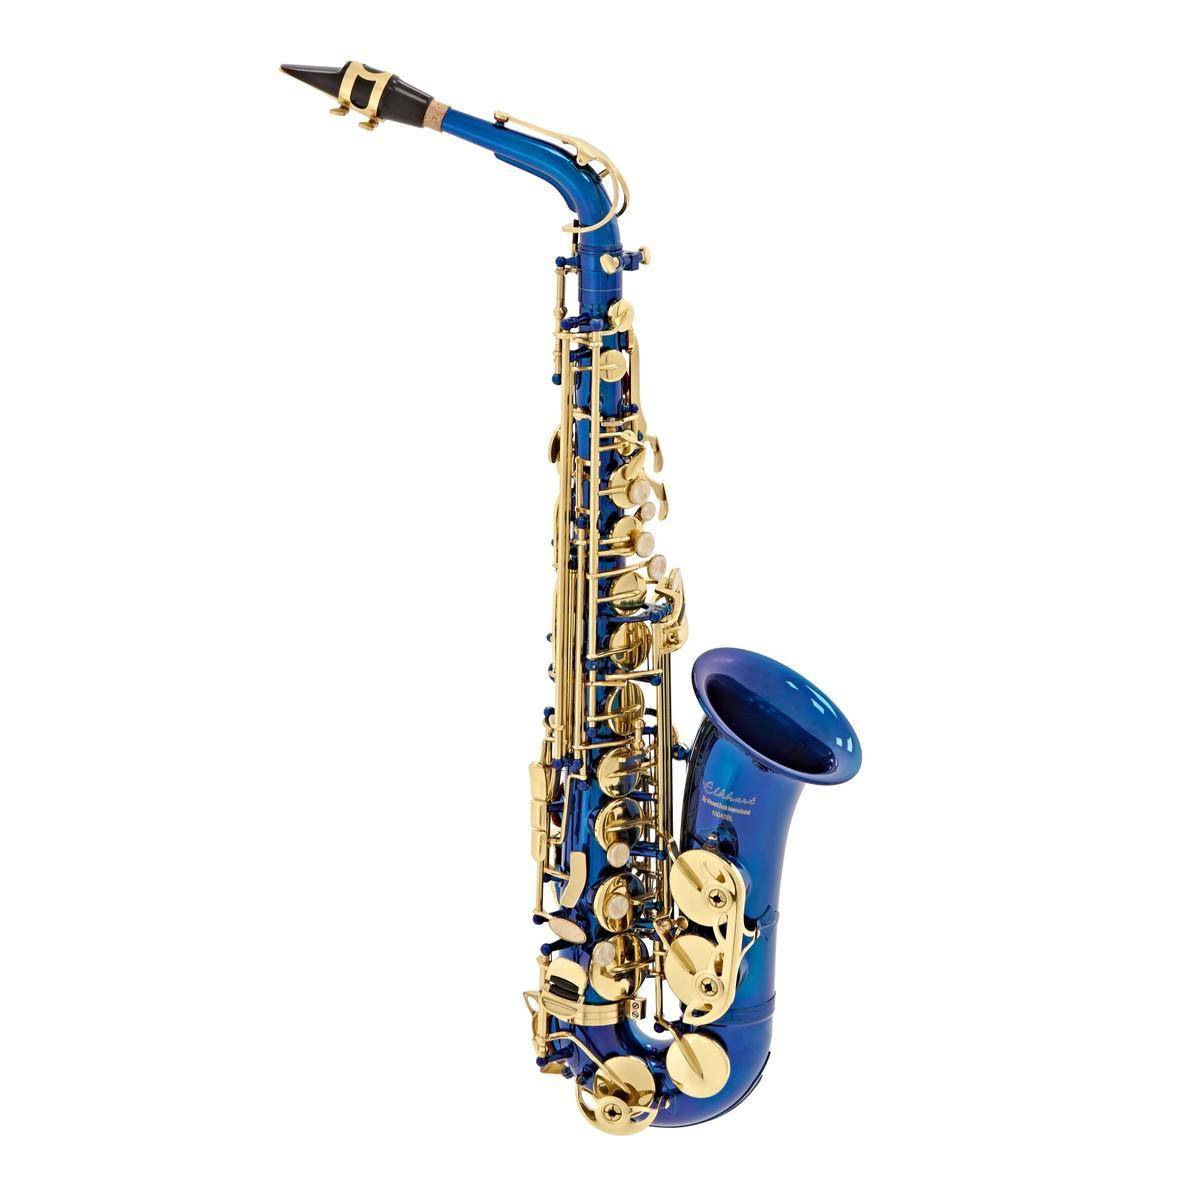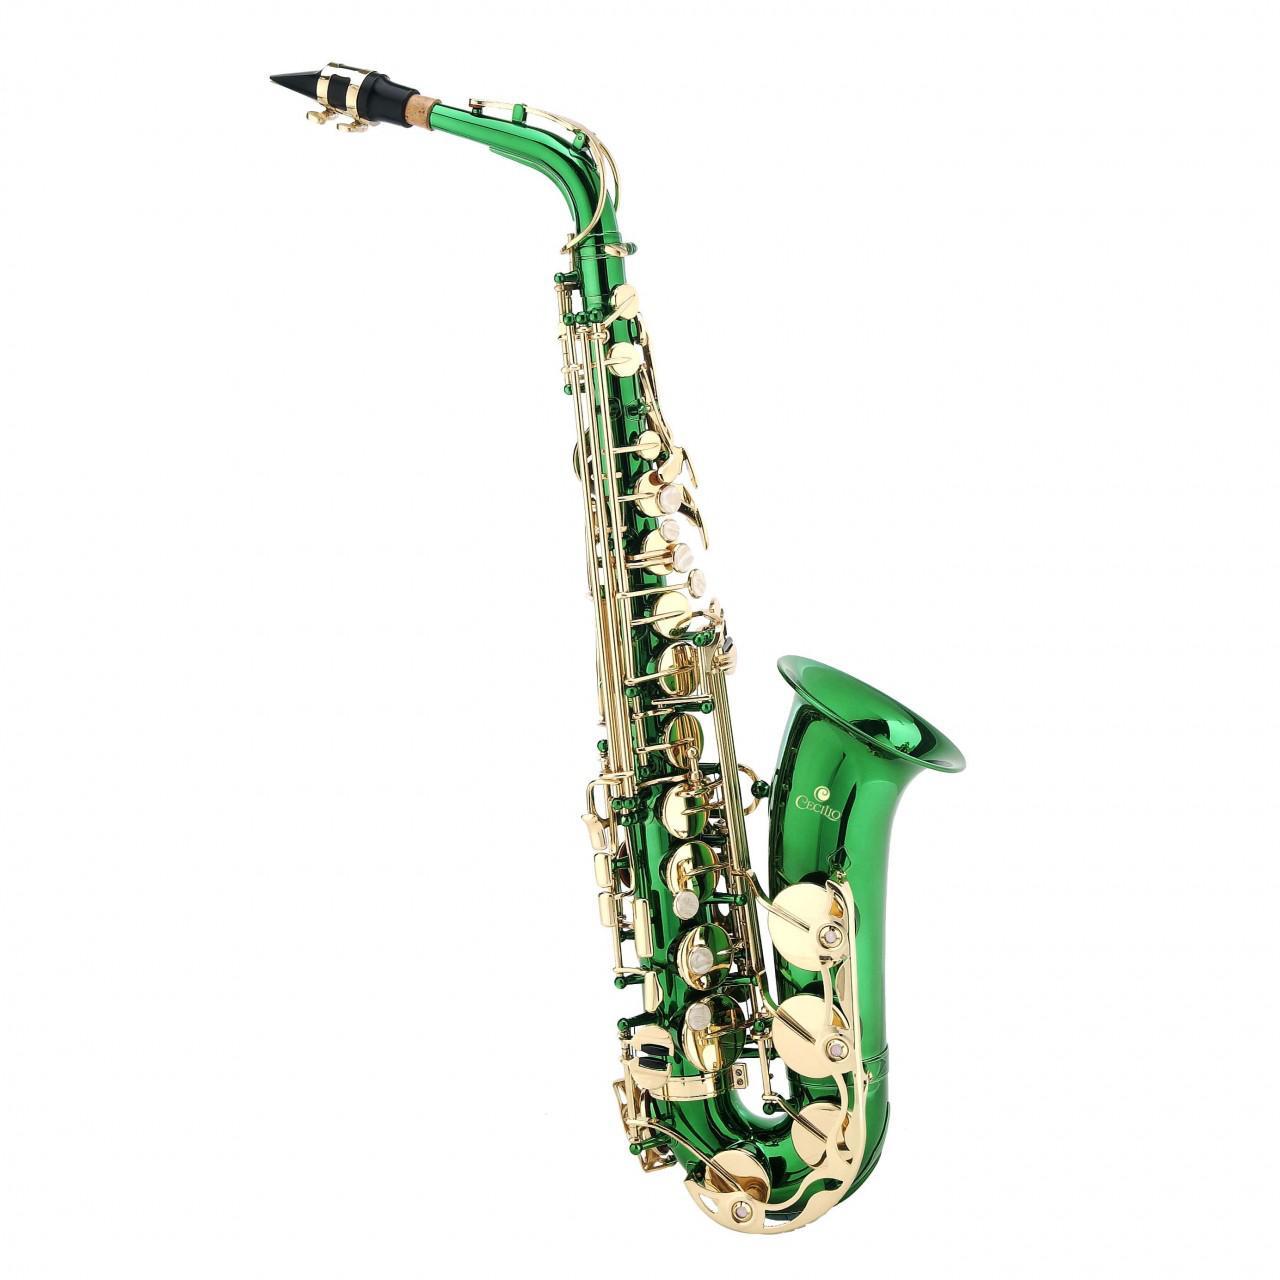The first image is the image on the left, the second image is the image on the right. Evaluate the accuracy of this statement regarding the images: "You can see an entire saxophone in both photos.". Is it true? Answer yes or no. Yes. 